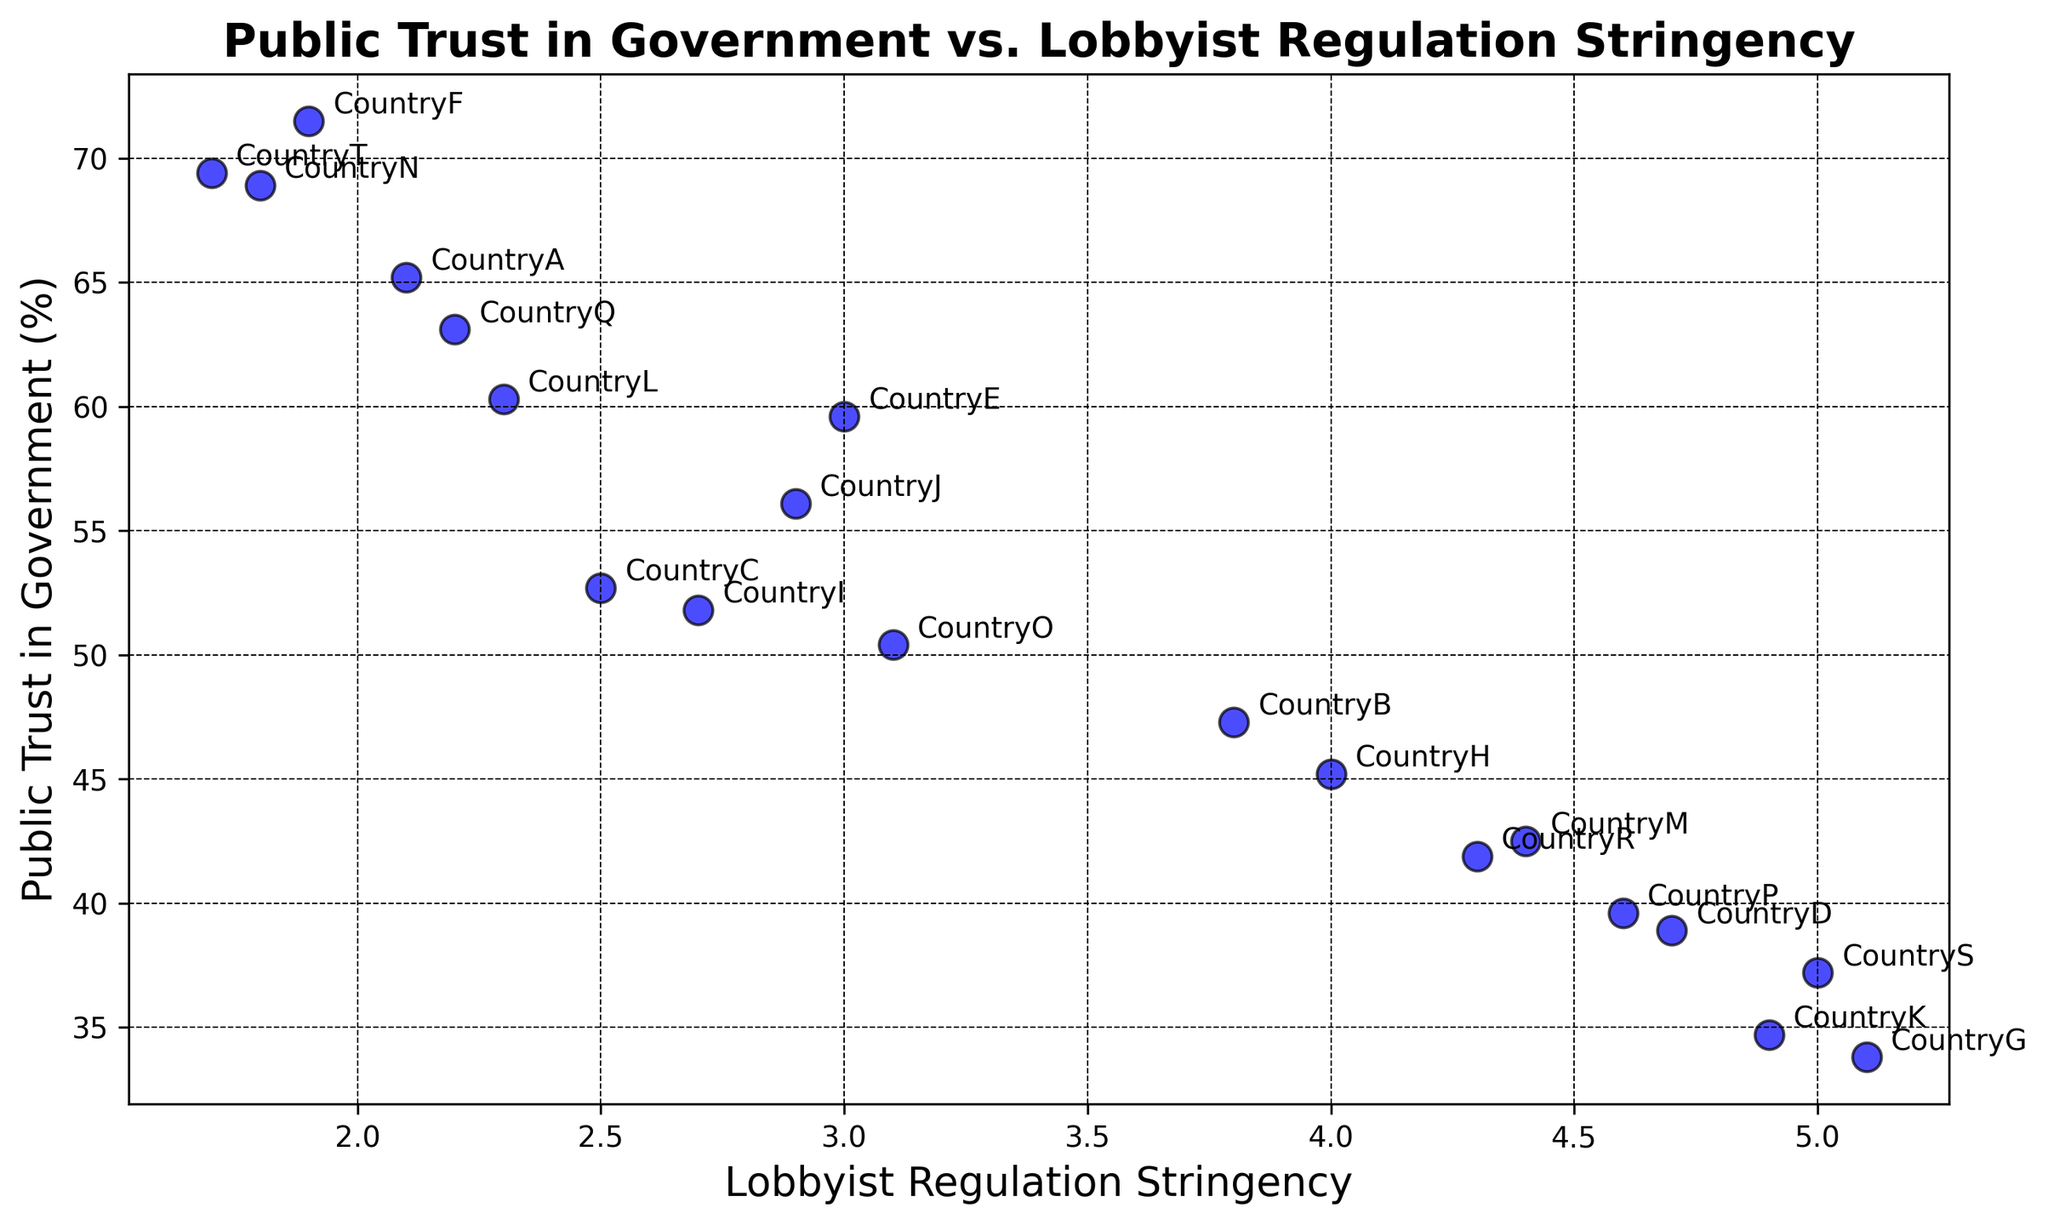What is the country with the highest public trust in government? By looking at the scatter plot, identify the point that is highest along the y-axis, representing public trust in government. CountryT has the highest value at 69.4%.
Answer: CountryT Which country has the strictest lobbyist regulation stringency? Locate the point that is furthest right along the x-axis, representing lobbyist regulation stringency. CountryG has the highest lobbyist regulation stringency at 5.1.
Answer: CountryG Which country has both moderate public trust in government and moderate lobbyist regulation stringency? Look for a point that lies in the middle range of both axes. CountryJ has a public trust of 56.1% and lobbyist regulation stringency of 2.9.
Answer: CountryJ Which country shows a higher public trust in government, CountryD or CountryM? Compare the vertical positions of CountryD and CountryM on the y-axis. CountryD has a public trust of 38.9%, and CountryM has 42.5%.
Answer: CountryM What is the average public trust in government for countries with lobbyist regulation stringency below 3.0? First, identify the countries below 3.0 stringency (CountryA, CountryC, CountryF, CountryI, CountryJ, CountryL, CountryN, CountryQ, CountryT) and calculate the average of their public trust values: (65.2 + 52.7 + 71.5 + 51.8 + 56.1 + 60.3 + 68.9 + 63.1 + 69.4) / 9 = 62.2
Answer: 62.2 Are there more countries above or below the median value of lobbyist regulation stringency? First, find the median value of lobbyist regulation stringency from the list of data points: 2.1, 2.2, 2.3, 2.5, 2.7, 2.9, 3.0, 3.1, 3.8, 4.0, 4.3, 4.4, 4.6, 4.7, 4.9, 5.0, 5.1. The median is 3.0. Count the number of countries below and above this value: Below (8), Above (9). There are more above.
Answer: Above Is there a visible trend between public trust in government and lobbyist regulation stringency? Observe the general direction of the data points. As lobbyist regulation stringency increases (x-axis), public trust in government (y-axis) generally decreases.
Answer: Public trust decreases Which country has the lowest public trust in government? Identify the point that is lowest along the y-axis, representing public trust in government. CountryG has the lowest value with 33.8%.
Answer: CountryG Which countries have a public trust in government above 60%? Identify points with y-values above 60.0%. Countries are CountryA (65.2), CountryF (71.5), CountryN (68.9), CountryQ (63.1), CountryL (60.3), CountryT (69.4).
Answer: CountryA, CountryF, CountryN, CountryQ, CountryL, CountryT 